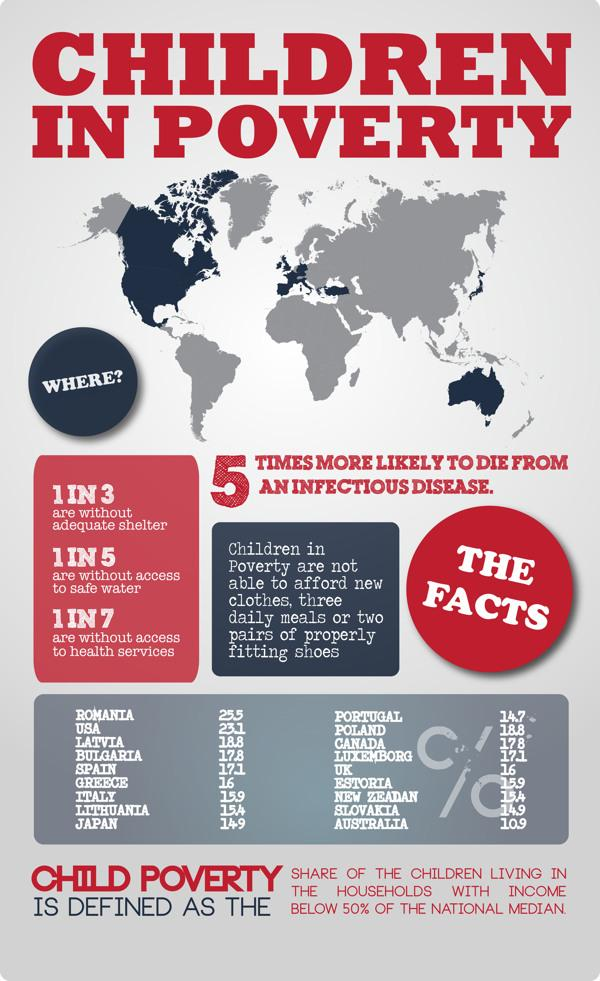Identify some key points in this picture. Romania has the highest number of children living in poverty among all countries. Spain has the fifth largest percentage of children living in poverty among all countries. Japan has the ninth largest percentage of children in poverty among all countries, according to recent estimates. The United States has the second highest percentage of children living in poverty, a statistic that is unacceptable and must be addressed by policymakers. According to recent statistics, Greece has the sixth highest percentage of children living in poverty among all countries in the world. 